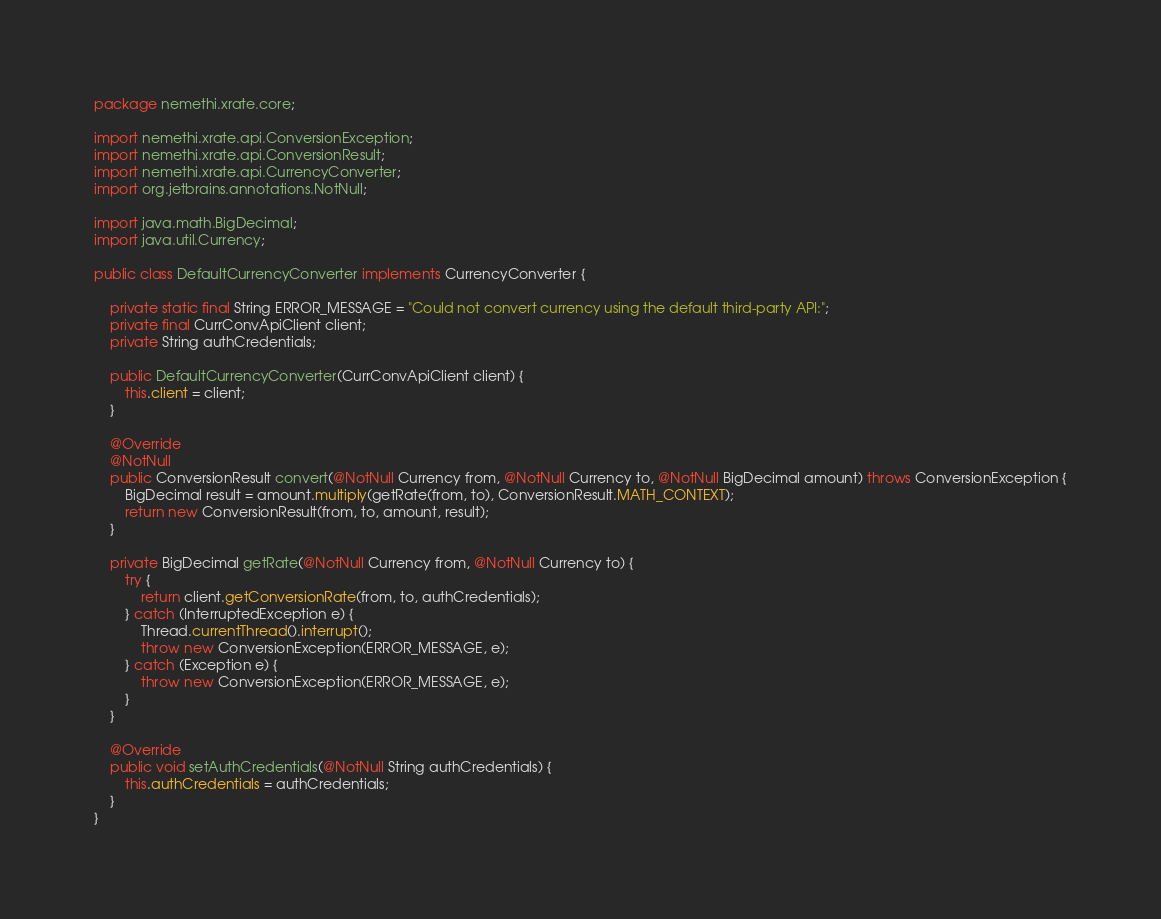<code> <loc_0><loc_0><loc_500><loc_500><_Java_>package nemethi.xrate.core;

import nemethi.xrate.api.ConversionException;
import nemethi.xrate.api.ConversionResult;
import nemethi.xrate.api.CurrencyConverter;
import org.jetbrains.annotations.NotNull;

import java.math.BigDecimal;
import java.util.Currency;

public class DefaultCurrencyConverter implements CurrencyConverter {

    private static final String ERROR_MESSAGE = "Could not convert currency using the default third-party API:";
    private final CurrConvApiClient client;
    private String authCredentials;

    public DefaultCurrencyConverter(CurrConvApiClient client) {
        this.client = client;
    }

    @Override
    @NotNull
    public ConversionResult convert(@NotNull Currency from, @NotNull Currency to, @NotNull BigDecimal amount) throws ConversionException {
        BigDecimal result = amount.multiply(getRate(from, to), ConversionResult.MATH_CONTEXT);
        return new ConversionResult(from, to, amount, result);
    }

    private BigDecimal getRate(@NotNull Currency from, @NotNull Currency to) {
        try {
            return client.getConversionRate(from, to, authCredentials);
        } catch (InterruptedException e) {
            Thread.currentThread().interrupt();
            throw new ConversionException(ERROR_MESSAGE, e);
        } catch (Exception e) {
            throw new ConversionException(ERROR_MESSAGE, e);
        }
    }

    @Override
    public void setAuthCredentials(@NotNull String authCredentials) {
        this.authCredentials = authCredentials;
    }
}
</code> 